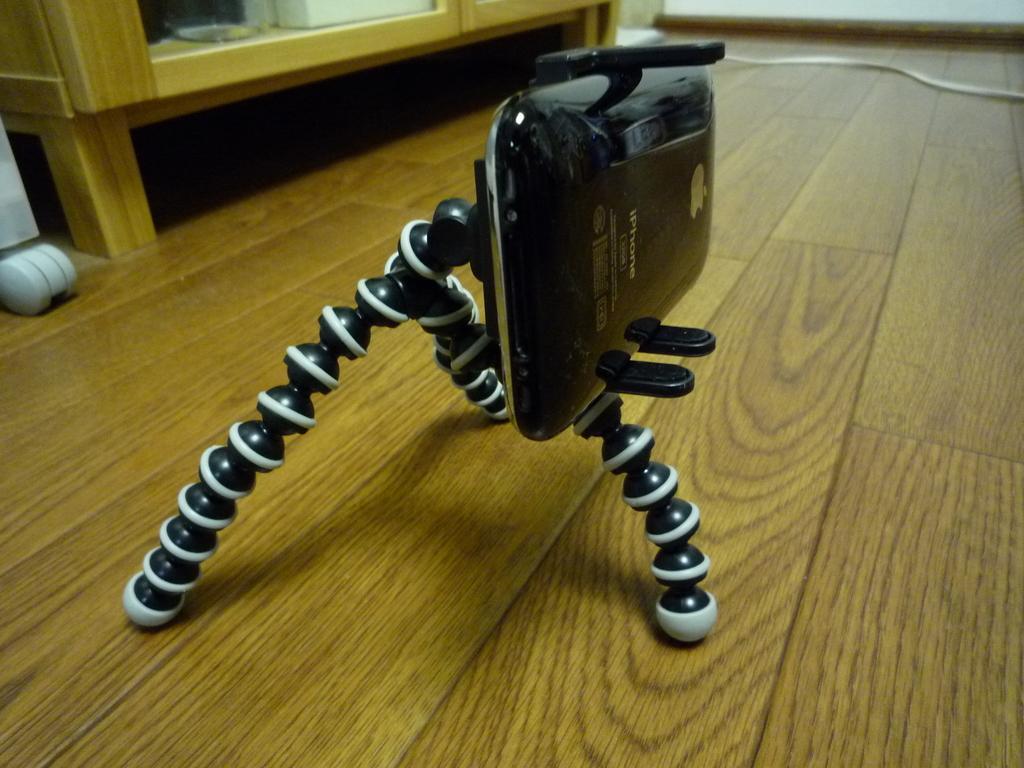Please provide a concise description of this image. In this picture we can see a black stand with a mobile on the wooden object and on the object there is a cable and other things. 